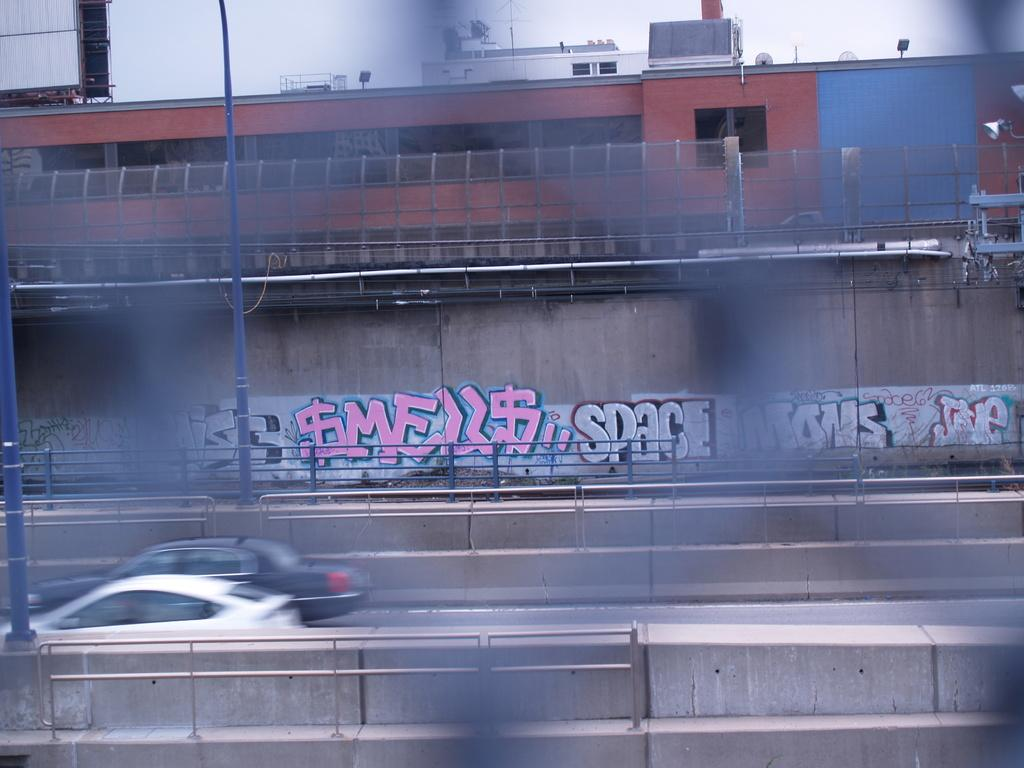Provide a one-sentence caption for the provided image. An urban wall seen through a chain-link fence has graffiti on it that reads $mell$. 